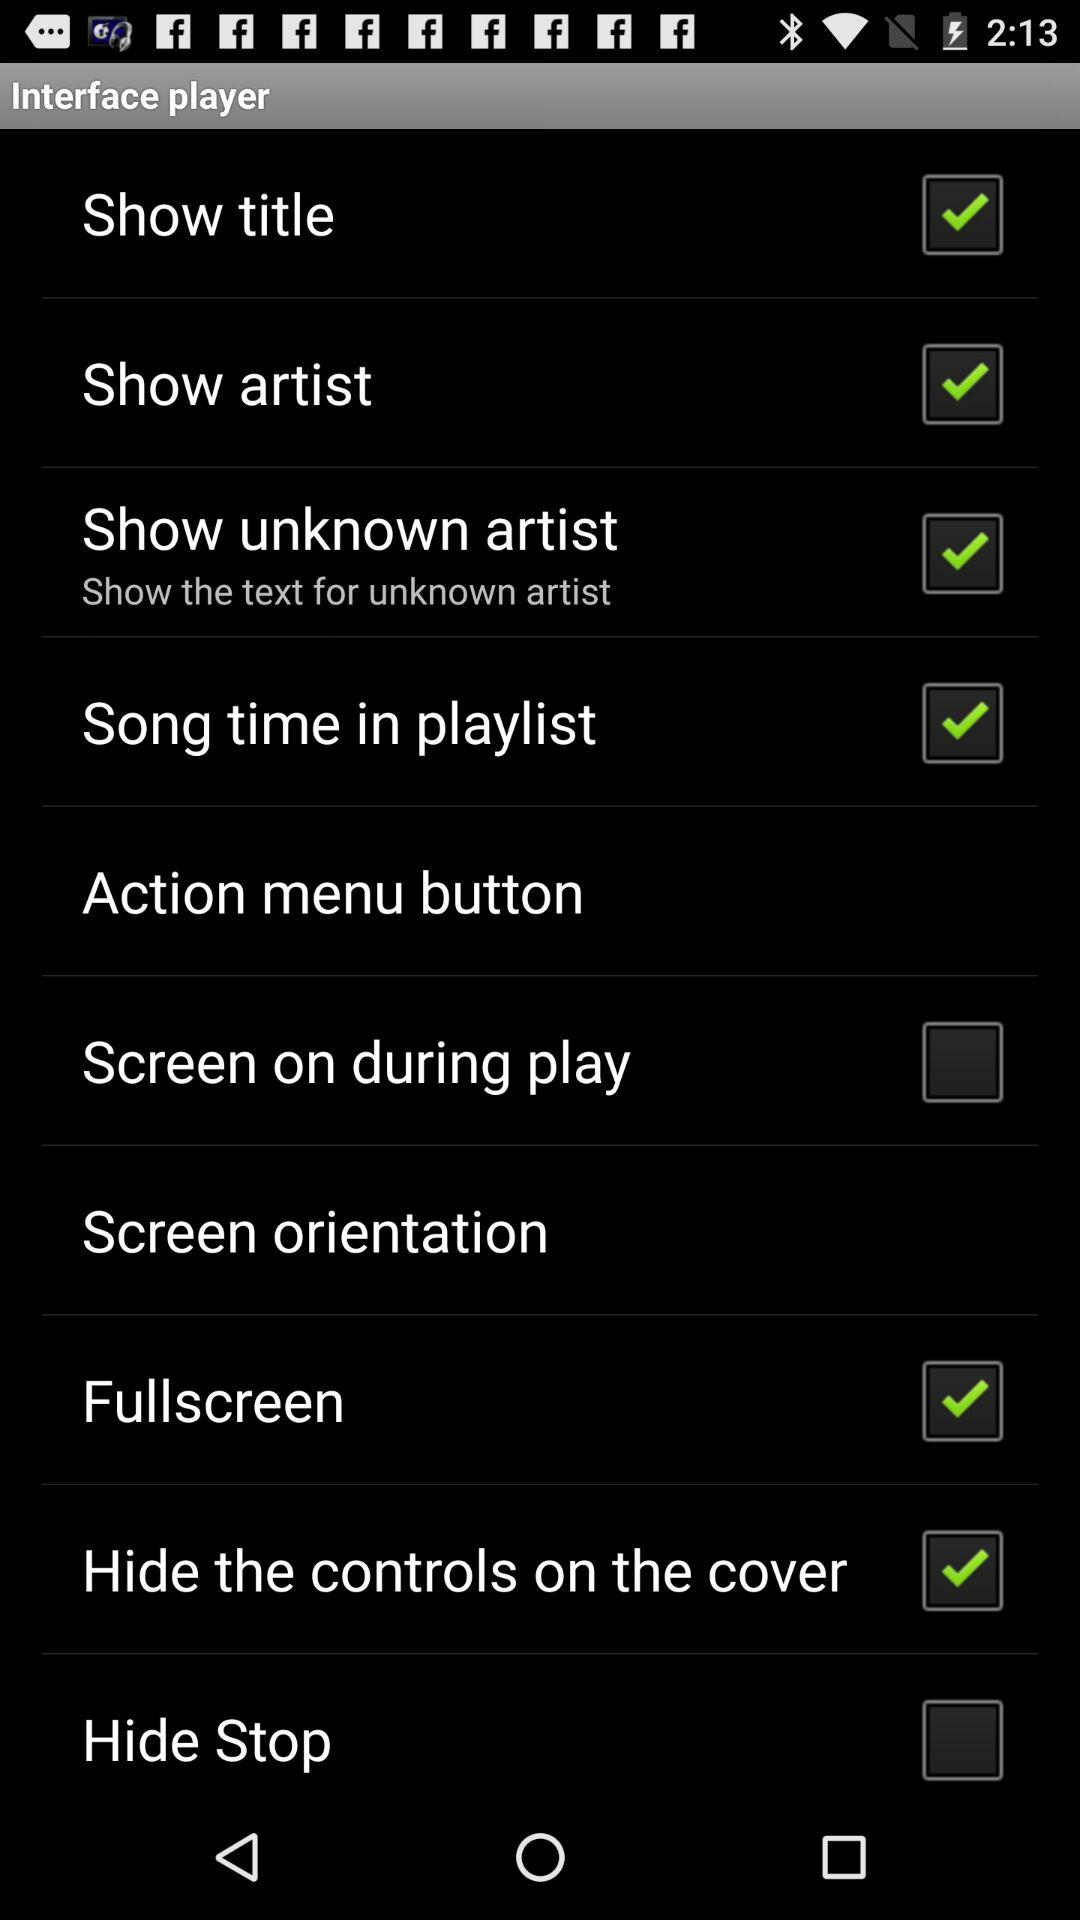What is the status of the "Hide Stop"? The status is "off". 